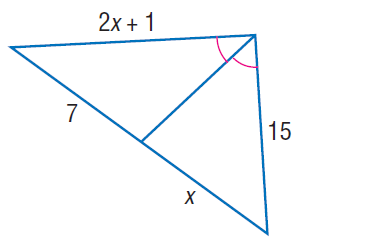Answer the mathemtical geometry problem and directly provide the correct option letter.
Question: Find x.
Choices: A: 7 B: 9 C: 11 D: 15 A 